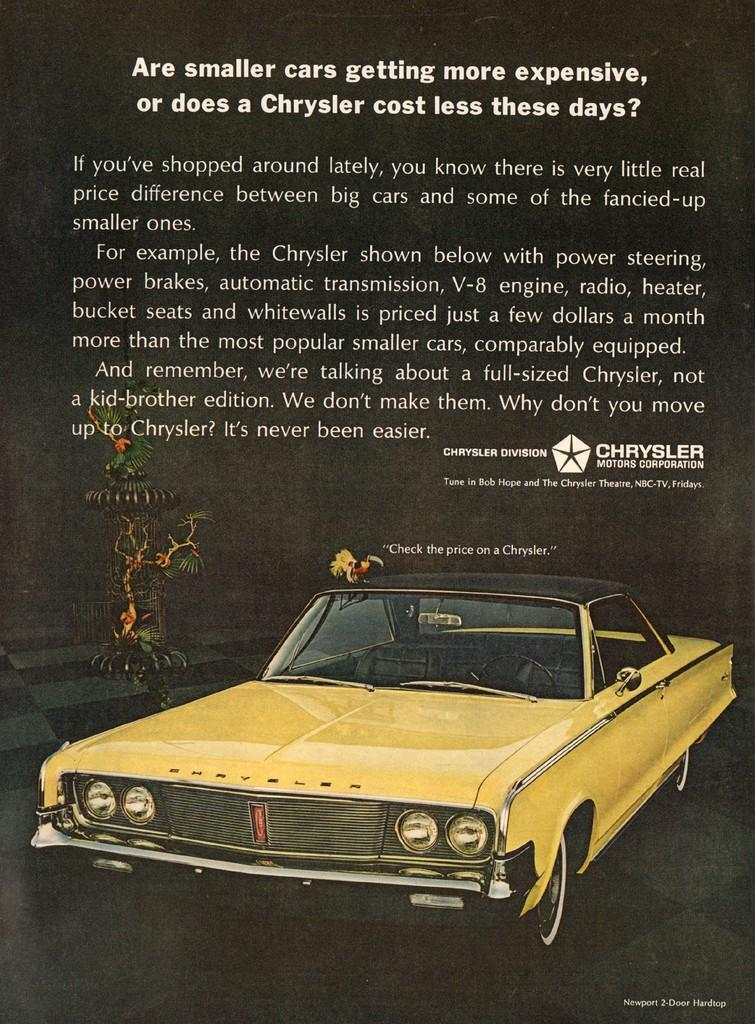What is featured on the poster in the image? There is a poster with text in the image. What type of vehicle can be seen in the image? There is a yellow-colored car in the image. Is there any living creature on the car? Yes, a bird is present on the car. What object resembles a tree in the image? There is an object that resembles a tree in the image. How many cacti are visible in the image? There are no cacti present in the image. What type of bird can be seen flying in the sky in the image? There is no bird flying in the sky in the image; the bird is present on the car. 